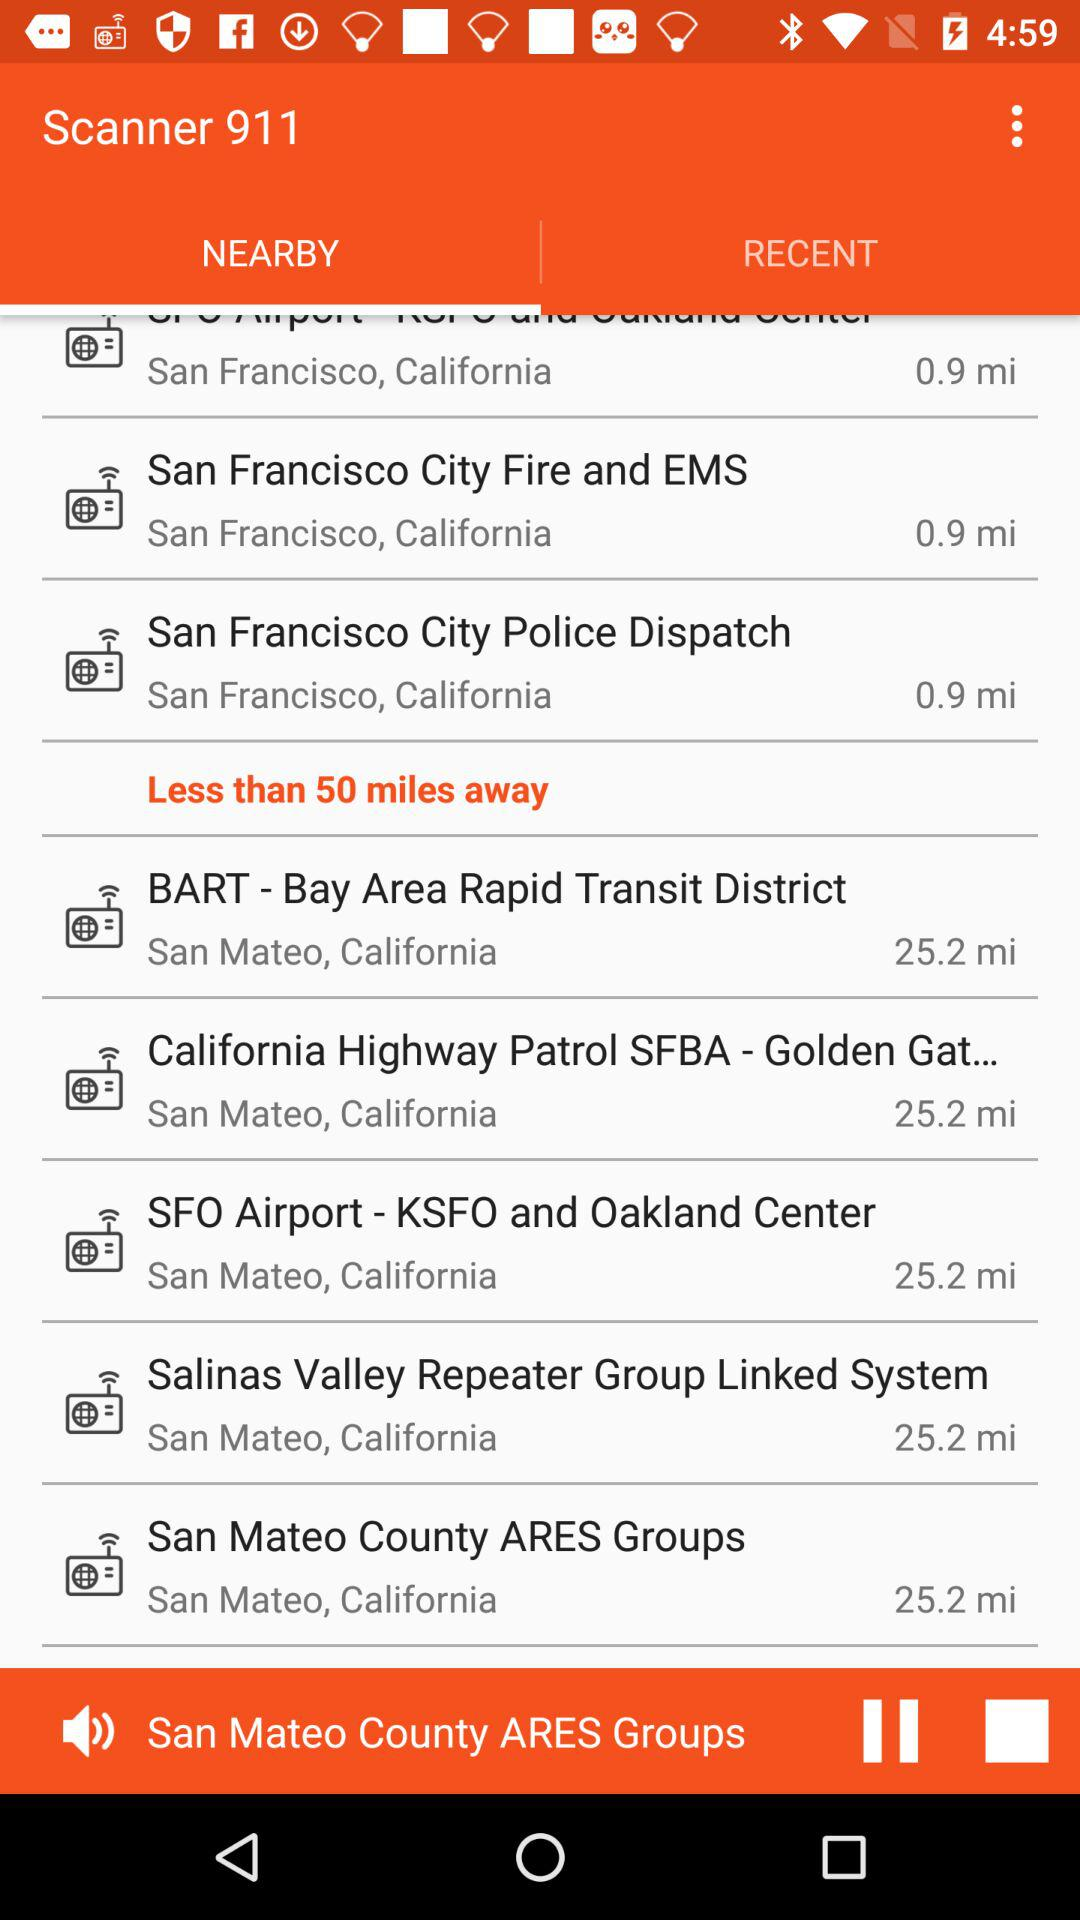How many miles away are "San Mateo County ARES Groups"? "San Mateo County ARES Groups" is 25.2 miles away. 